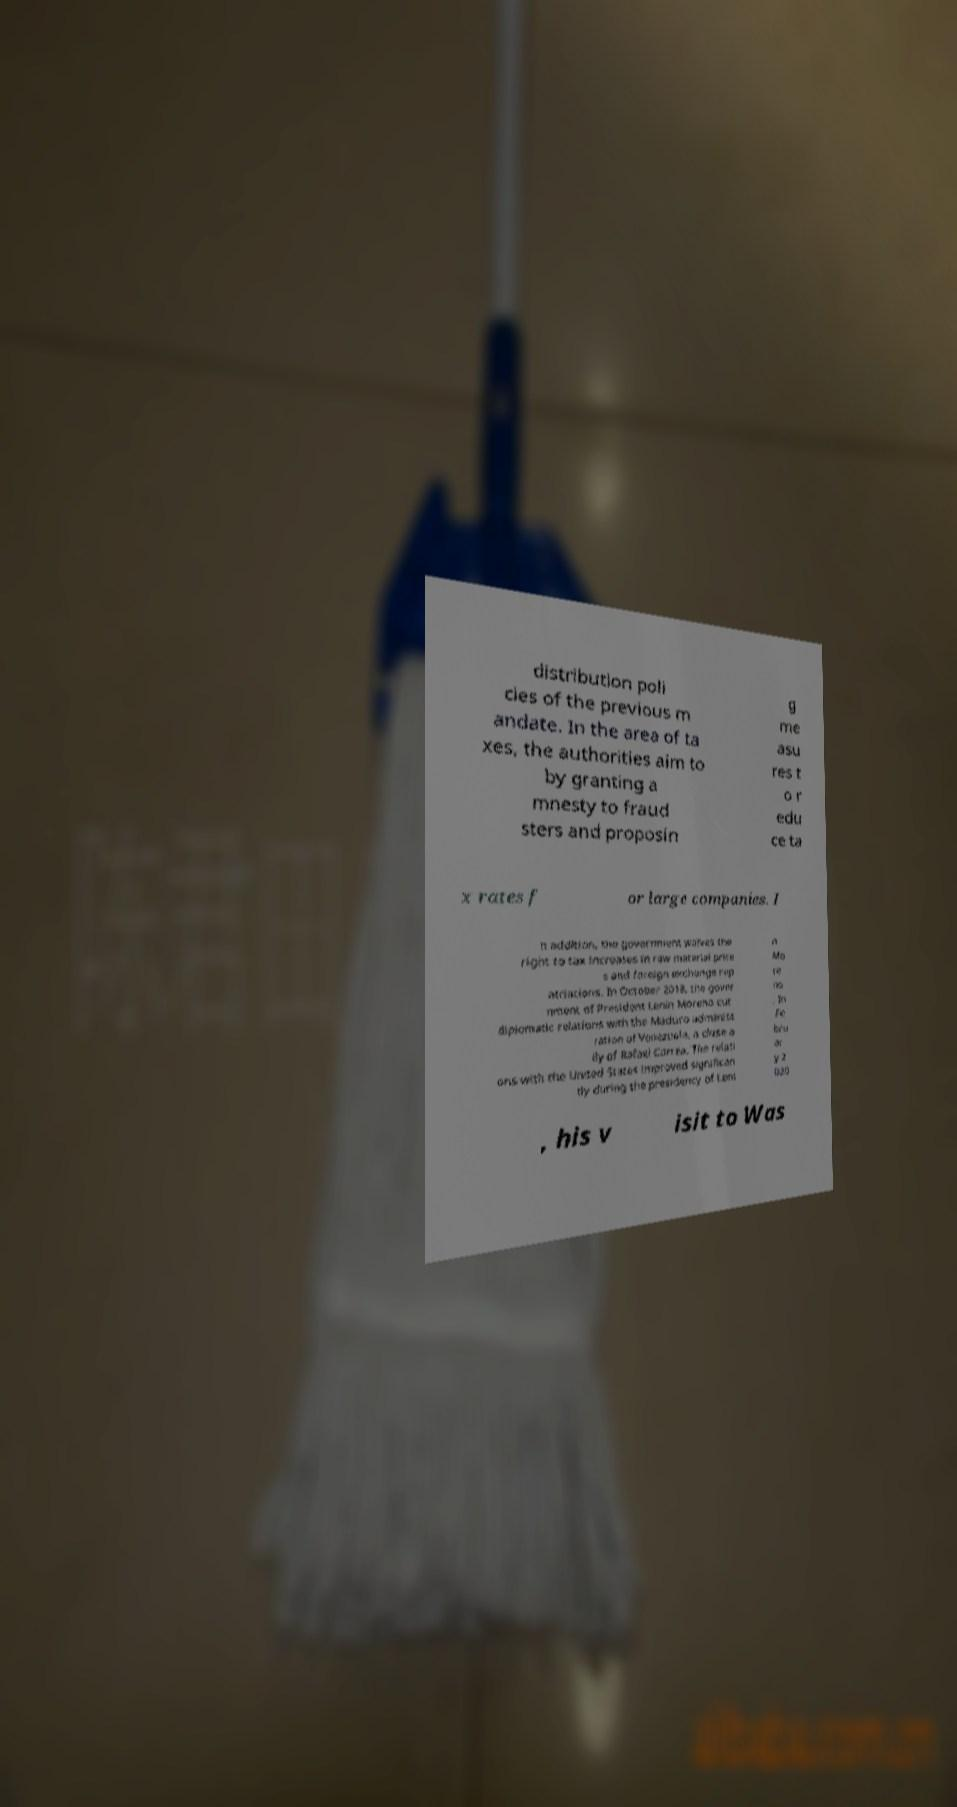Can you accurately transcribe the text from the provided image for me? distribution poli cies of the previous m andate. In the area of ta xes, the authorities aim to by granting a mnesty to fraud sters and proposin g me asu res t o r edu ce ta x rates f or large companies. I n addition, the government waives the right to tax increases in raw material price s and foreign exchange rep atriations. In October 2018, the gover nment of President Lenin Moreno cut diplomatic relations with the Maduro administ ration of Venezuela, a close a lly of Rafael Correa. The relati ons with the United States improved significan tly during the presidency of Leni n Mo re no . In Fe bru ar y 2 020 , his v isit to Was 